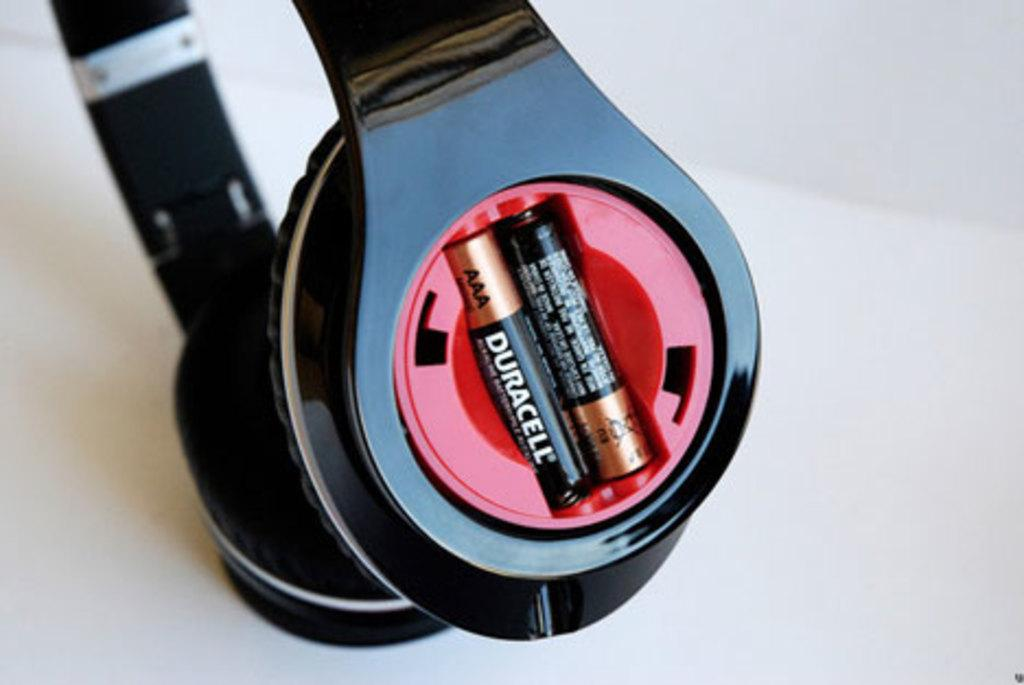<image>
Describe the image concisely. Two black batteries say "DURACELL" on the sides. 